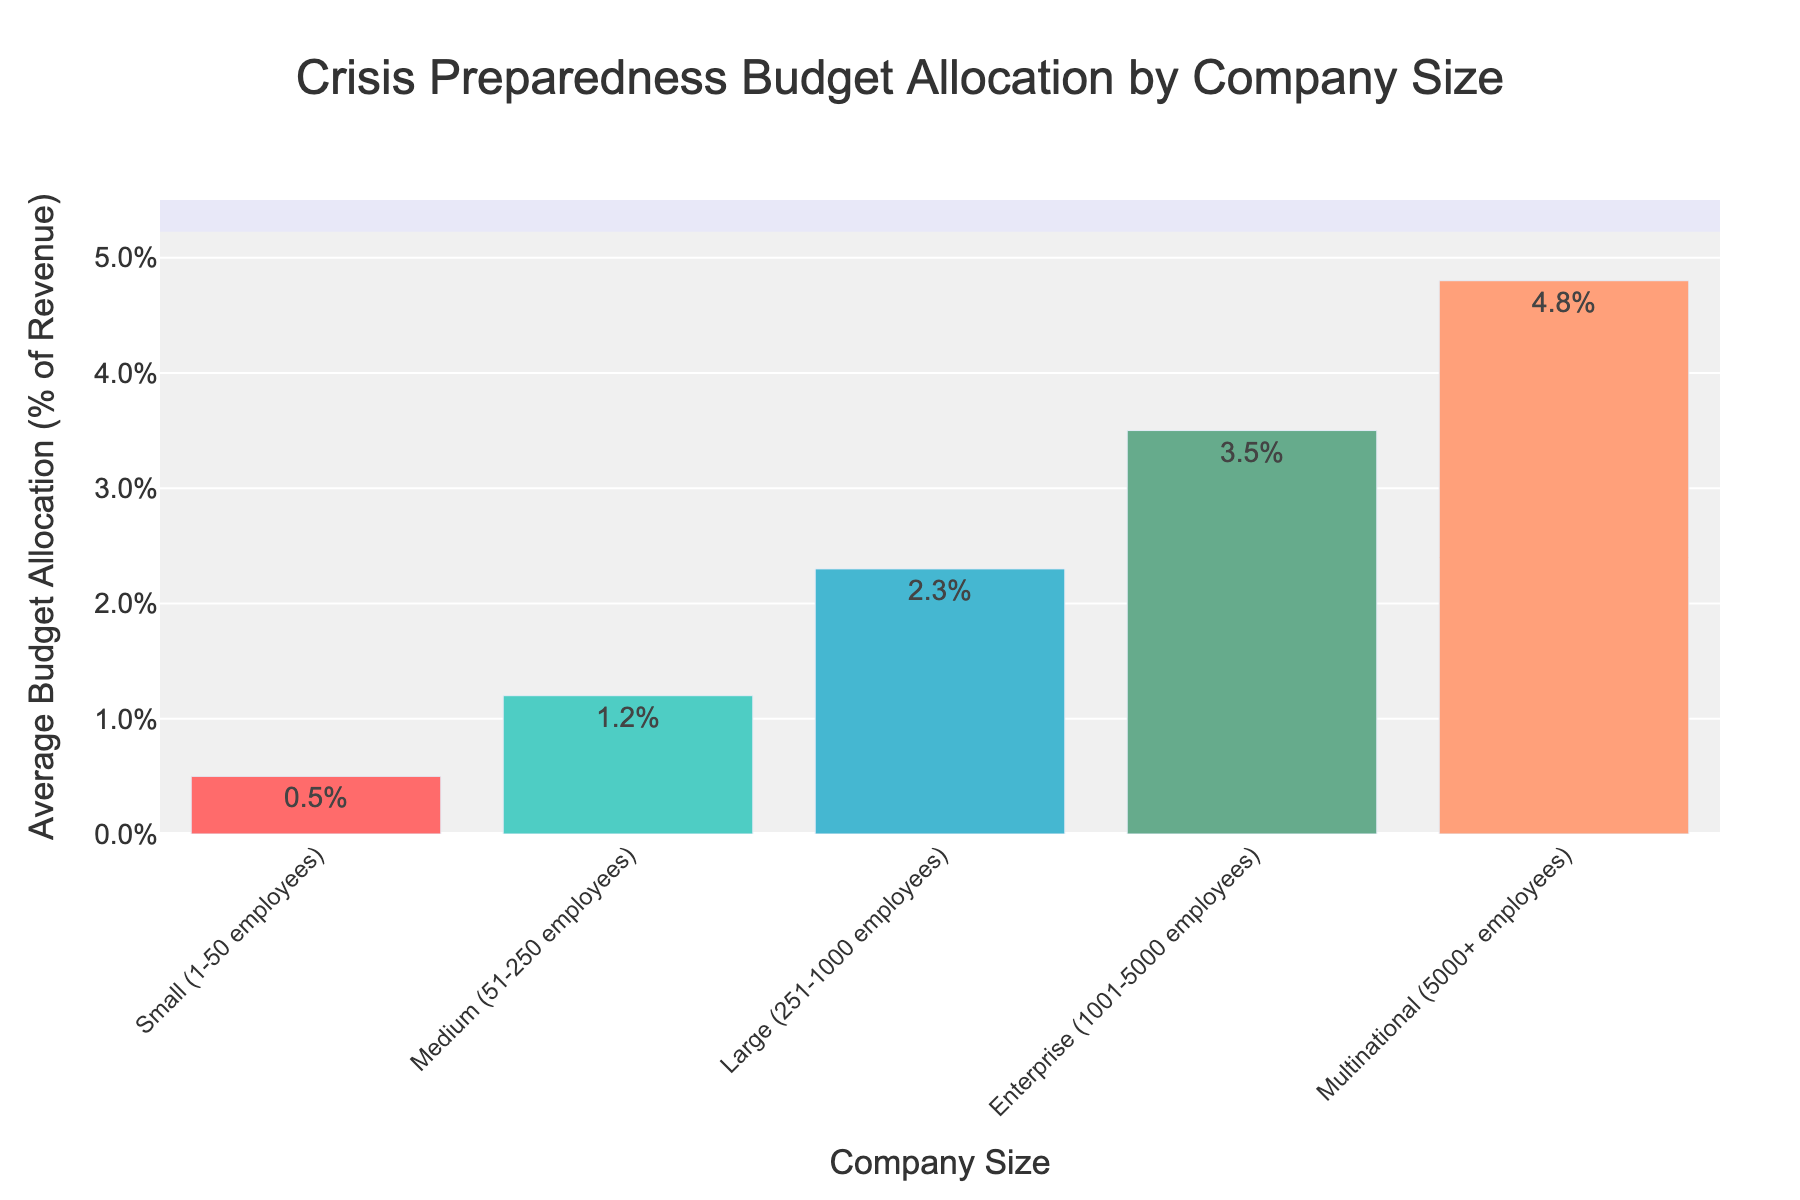Which company size has the highest budget allocation for crisis preparedness? By examining the heights of the bars, the "Multinational (5000+ employees)" bar is the tallest, indicating the highest budget allocation.
Answer: Multinational How much more budget allocation does an Enterprise company have compared to a Small company? The Enterprise company's budget allocation is 3.5%, while the Small company's is 0.5%. The difference is calculated as 3.5% - 0.5% = 3%.
Answer: 3% Is the budget allocation of a Medium company greater than that of a Small company? The Medium company's budget allocation is 1.2%, while the Small company's is 0.5%. Since 1.2% > 0.5%, the Medium company's allocation is greater.
Answer: Yes What is the combined budget allocation of Large and Enterprise companies? The Large company's allocation is 2.3%, and the Enterprise company's allocation is 3.5%. So, the combined allocation is 2.3% + 3.5% = 5.8%.
Answer: 5.8% Which company size has a budget allocation closest to the average of all allocations? To find the average allocation: (0.5 + 1.2 + 2.3 + 3.5 + 4.8) / 5 = 2.46%. The Large company has an allocation of 2.3%, which is closest to the average of 2.46%.
Answer: Large In terms of budget allocation for crisis preparedness, how does a Small company compare to a Large company? A Small company allocates 0.5% of its revenue, whereas a Large company allocates 2.3%. The Large company allocates 1.8% more than the Small company.
Answer: Large allocates 1.8% more Rank the companies from highest to lowest based on their budget allocation for crisis preparedness. The budget allocations from highest to lowest are: Multinational (4.8%), Enterprise (3.5%), Large (2.3%), Medium (1.2%), Small (0.5%).
Answer: Multinational > Enterprise > Large > Medium > Small What percent of the total budget allocation is attributed to Medium and Enterprise companies together? Combined allocation = 1.2% + 3.5% = 4.7%. Total allocation = 0.5 + 1.2 + 2.3 + 3.5 + 4.8 = 12.3%. The percent attributed to both is (4.7 / 12.3) * 100 ≈ 38.2%.
Answer: 38.2% Identify the company sizes that allocate above the overall average budget for crisis preparedness. The overall average budget allocation is 2.46%. The companies with allocations above this average are Large (2.3% < 2.46%) and above: Enterprise (3.5%) and Multinational (4.8%).
Answer: Enterprise and Multinational 